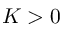Convert formula to latex. <formula><loc_0><loc_0><loc_500><loc_500>K > 0</formula> 